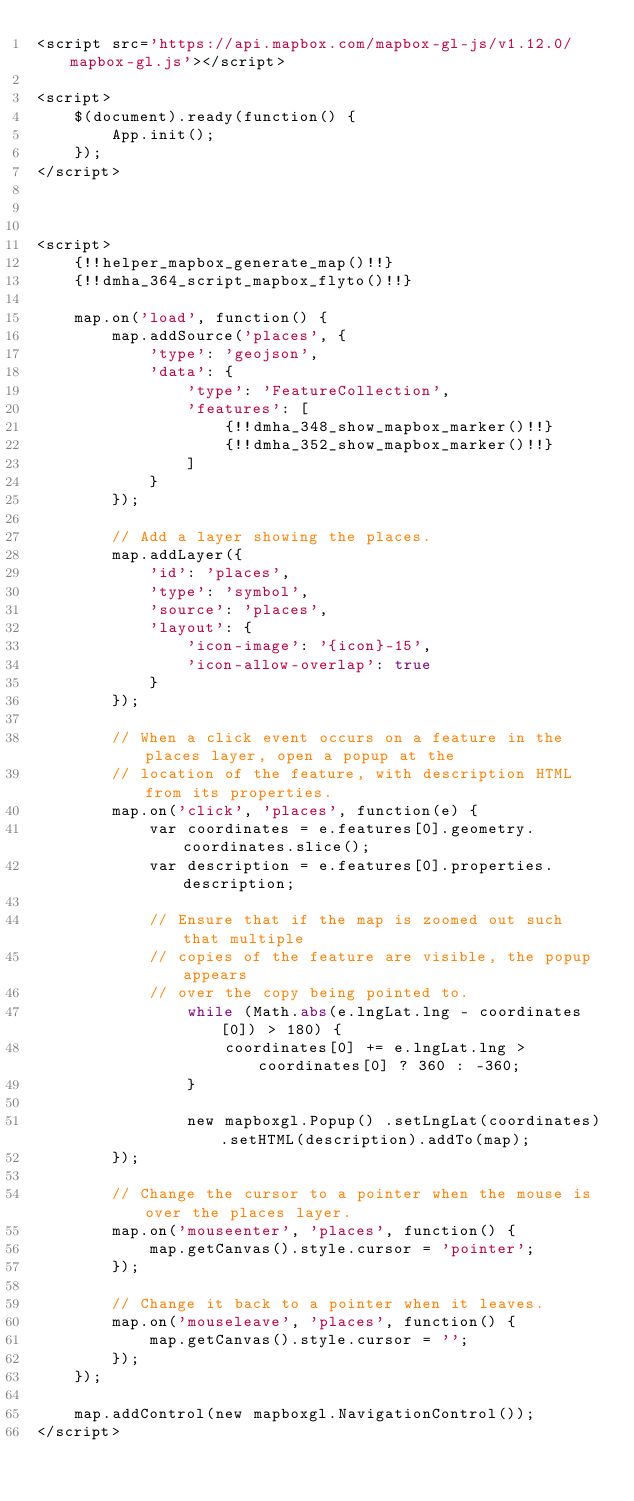Convert code to text. <code><loc_0><loc_0><loc_500><loc_500><_PHP_><script src='https://api.mapbox.com/mapbox-gl-js/v1.12.0/mapbox-gl.js'></script>

<script>
    $(document).ready(function() {
        App.init();
    });
</script>



<script>
    {!!helper_mapbox_generate_map()!!} 
    {!!dmha_364_script_mapbox_flyto()!!}
    
    map.on('load', function() {
        map.addSource('places', {
            'type': 'geojson',
            'data': {
                'type': 'FeatureCollection',
                'features': [
                    {!!dmha_348_show_mapbox_marker()!!}
                    {!!dmha_352_show_mapbox_marker()!!}
                ]
            }
        });

        // Add a layer showing the places.
        map.addLayer({
            'id': 'places',
            'type': 'symbol',
            'source': 'places',
            'layout': {
                'icon-image': '{icon}-15',
                'icon-allow-overlap': true
            }
        });
        
        // When a click event occurs on a feature in the places layer, open a popup at the
        // location of the feature, with description HTML from its properties.
        map.on('click', 'places', function(e) {
            var coordinates = e.features[0].geometry.coordinates.slice();
            var description = e.features[0].properties.description;

            // Ensure that if the map is zoomed out such that multiple
            // copies of the feature are visible, the popup appears
            // over the copy being pointed to.
                while (Math.abs(e.lngLat.lng - coordinates[0]) > 180) {
                    coordinates[0] += e.lngLat.lng > coordinates[0] ? 360 : -360;
                }
            
                new mapboxgl.Popup() .setLngLat(coordinates).setHTML(description).addTo(map);
        });
    
        // Change the cursor to a pointer when the mouse is over the places layer.
        map.on('mouseenter', 'places', function() {
            map.getCanvas().style.cursor = 'pointer';
        });
    
        // Change it back to a pointer when it leaves.
        map.on('mouseleave', 'places', function() {
            map.getCanvas().style.cursor = '';
        });
    });
    
    map.addControl(new mapboxgl.NavigationControl());
</script></code> 